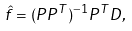Convert formula to latex. <formula><loc_0><loc_0><loc_500><loc_500>\hat { f } = ( P P ^ { T } ) ^ { - 1 } P ^ { T } D ,</formula> 